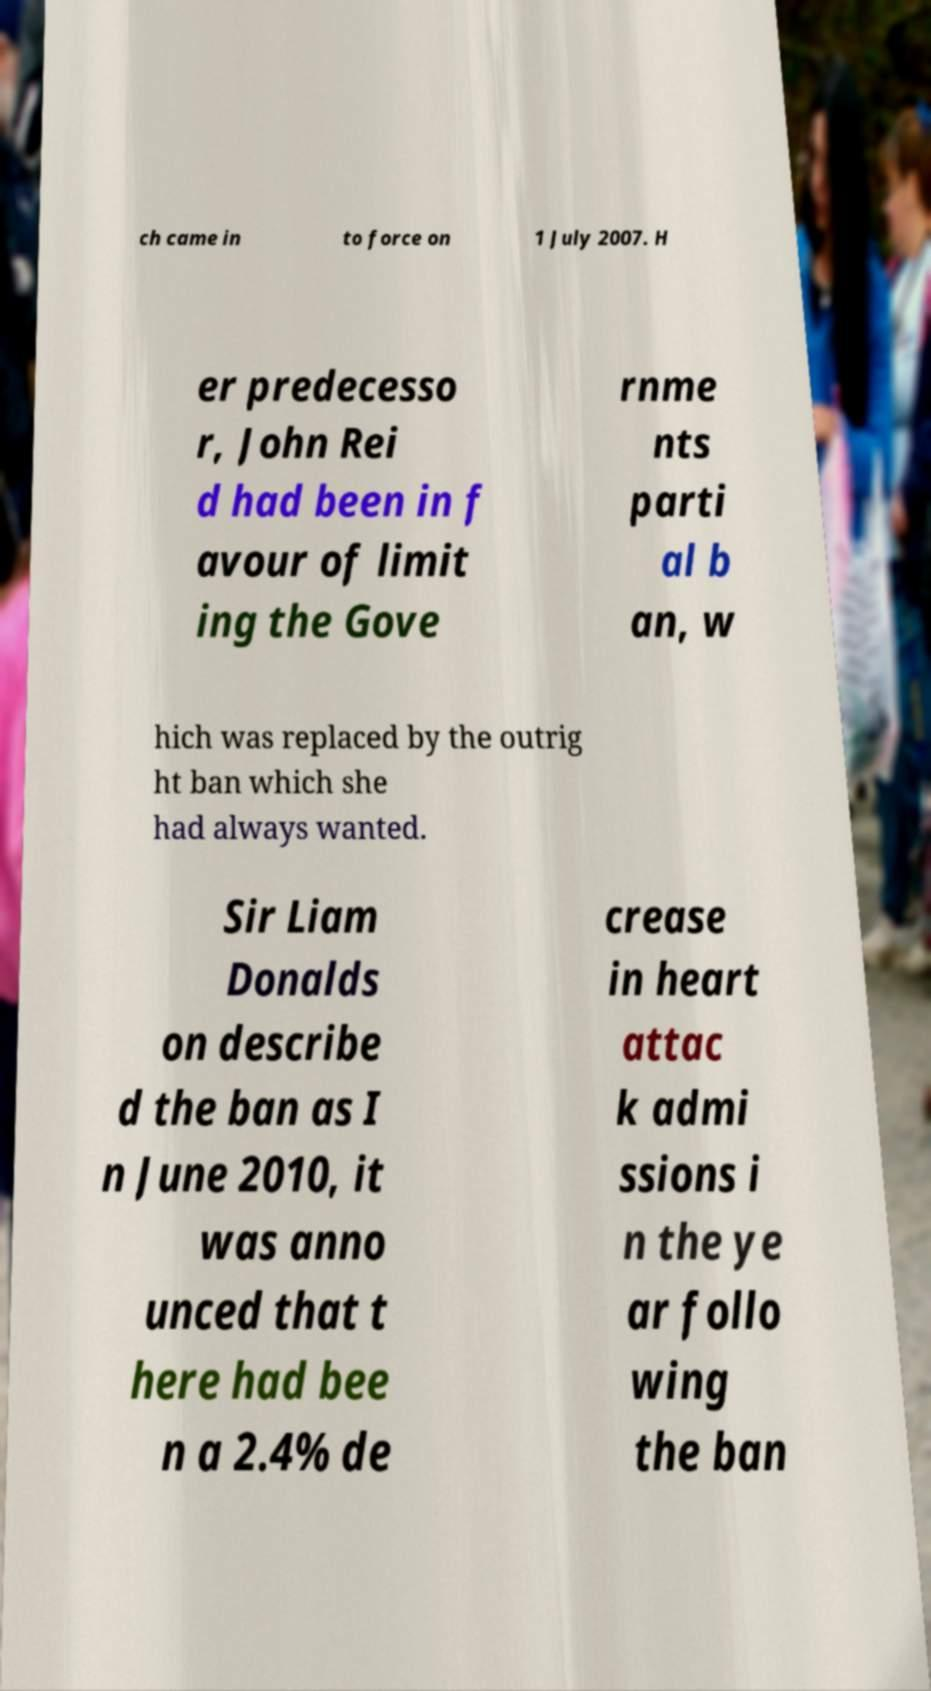Could you assist in decoding the text presented in this image and type it out clearly? ch came in to force on 1 July 2007. H er predecesso r, John Rei d had been in f avour of limit ing the Gove rnme nts parti al b an, w hich was replaced by the outrig ht ban which she had always wanted. Sir Liam Donalds on describe d the ban as I n June 2010, it was anno unced that t here had bee n a 2.4% de crease in heart attac k admi ssions i n the ye ar follo wing the ban 